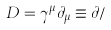Convert formula to latex. <formula><loc_0><loc_0><loc_500><loc_500>D = \gamma ^ { \mu } \partial _ { \mu } \equiv \partial /</formula> 